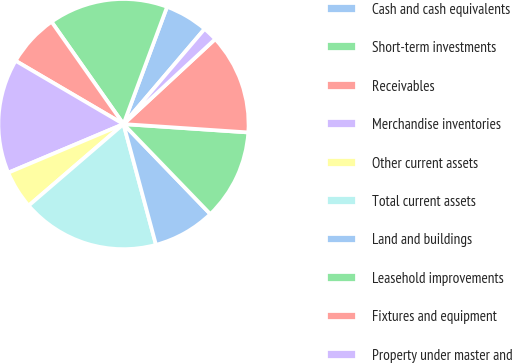Convert chart. <chart><loc_0><loc_0><loc_500><loc_500><pie_chart><fcel>Cash and cash equivalents<fcel>Short-term investments<fcel>Receivables<fcel>Merchandise inventories<fcel>Other current assets<fcel>Total current assets<fcel>Land and buildings<fcel>Leasehold improvements<fcel>Fixtures and equipment<fcel>Property under master and<nl><fcel>5.57%<fcel>15.42%<fcel>6.8%<fcel>14.8%<fcel>4.95%<fcel>17.88%<fcel>8.03%<fcel>11.72%<fcel>12.96%<fcel>1.87%<nl></chart> 